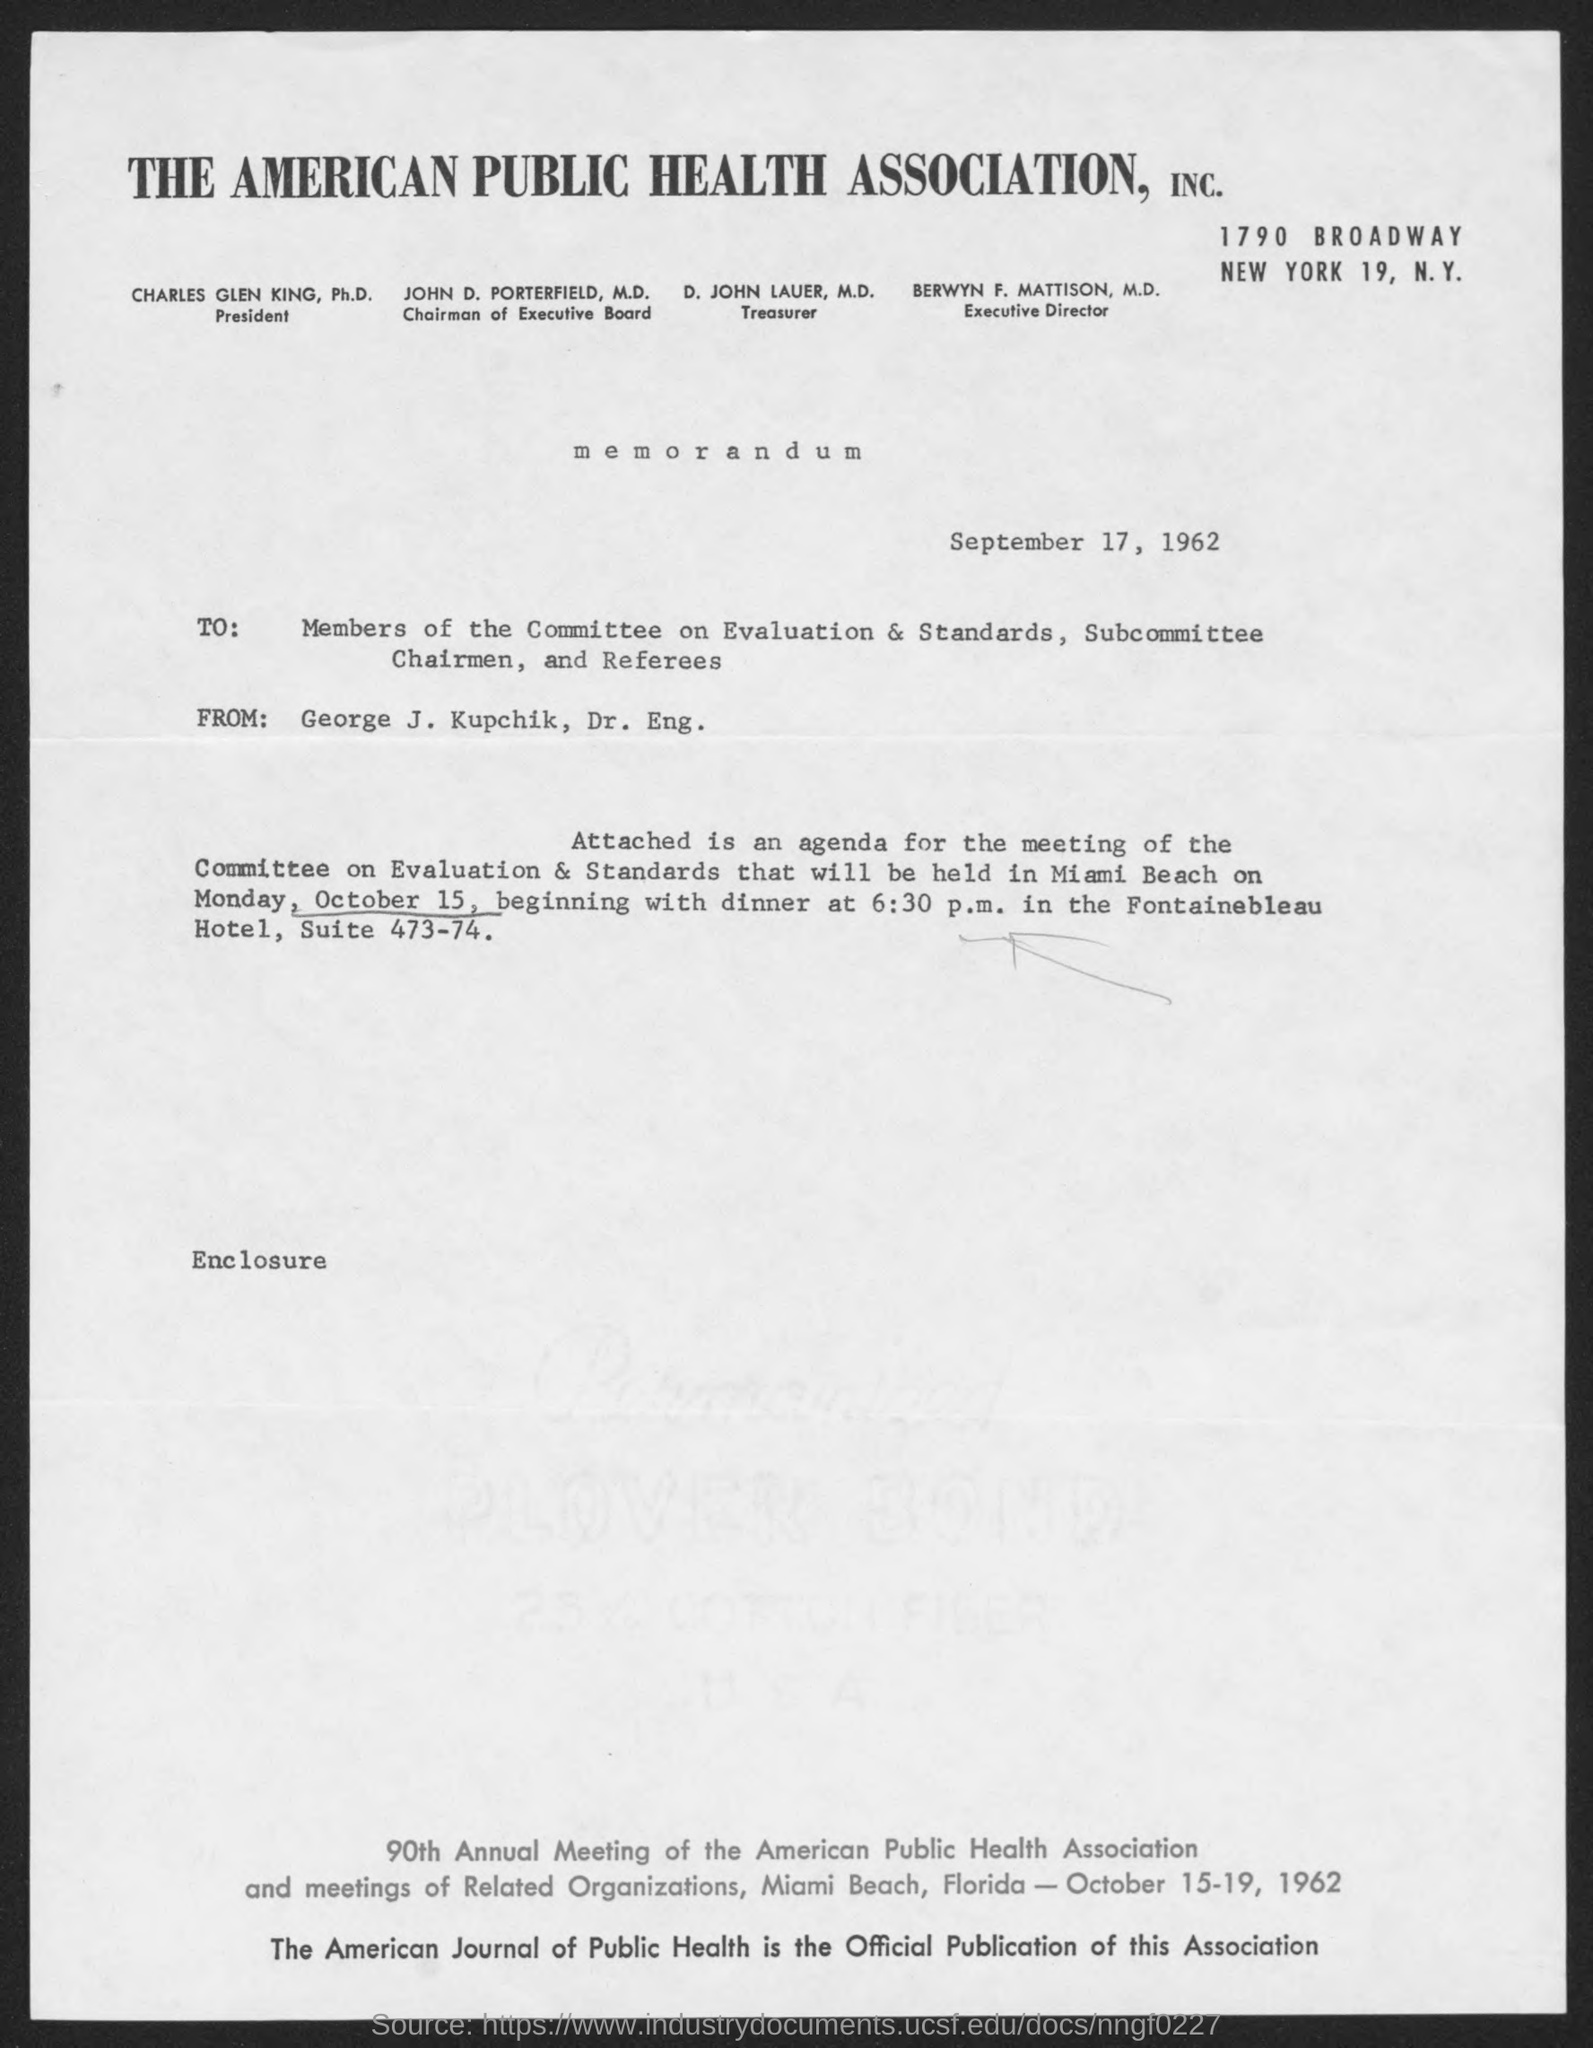Specify some key components in this picture. The meeting of the committee on Evaluation & Standards will be held on Monday, October 15. The date is September 17, 1962. The American Public Health Association does not have a Treasurer named John Lauer, MD. 